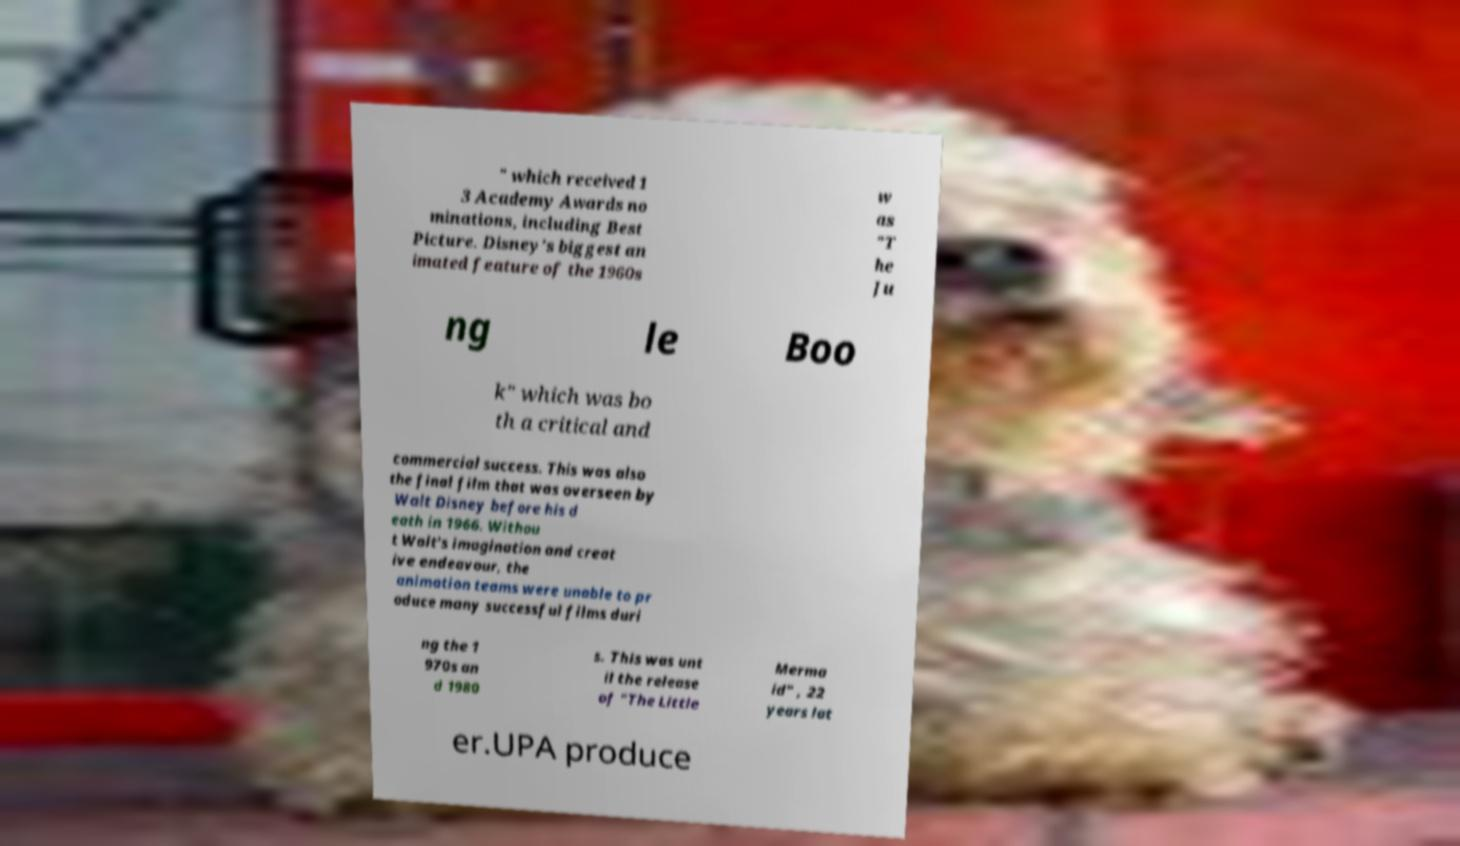For documentation purposes, I need the text within this image transcribed. Could you provide that? " which received 1 3 Academy Awards no minations, including Best Picture. Disney's biggest an imated feature of the 1960s w as "T he Ju ng le Boo k" which was bo th a critical and commercial success. This was also the final film that was overseen by Walt Disney before his d eath in 1966. Withou t Walt's imagination and creat ive endeavour, the animation teams were unable to pr oduce many successful films duri ng the 1 970s an d 1980 s. This was unt il the release of "The Little Merma id" , 22 years lat er.UPA produce 